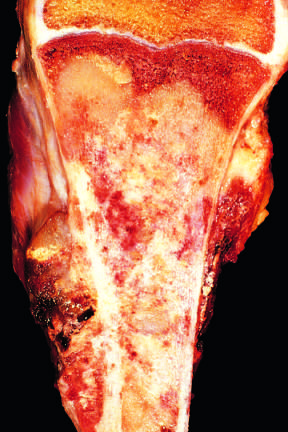what does the tan-white tumor fill?
Answer the question using a single word or phrase. Most of the medullary cavity of the metaphysis and proximal diaphysis 